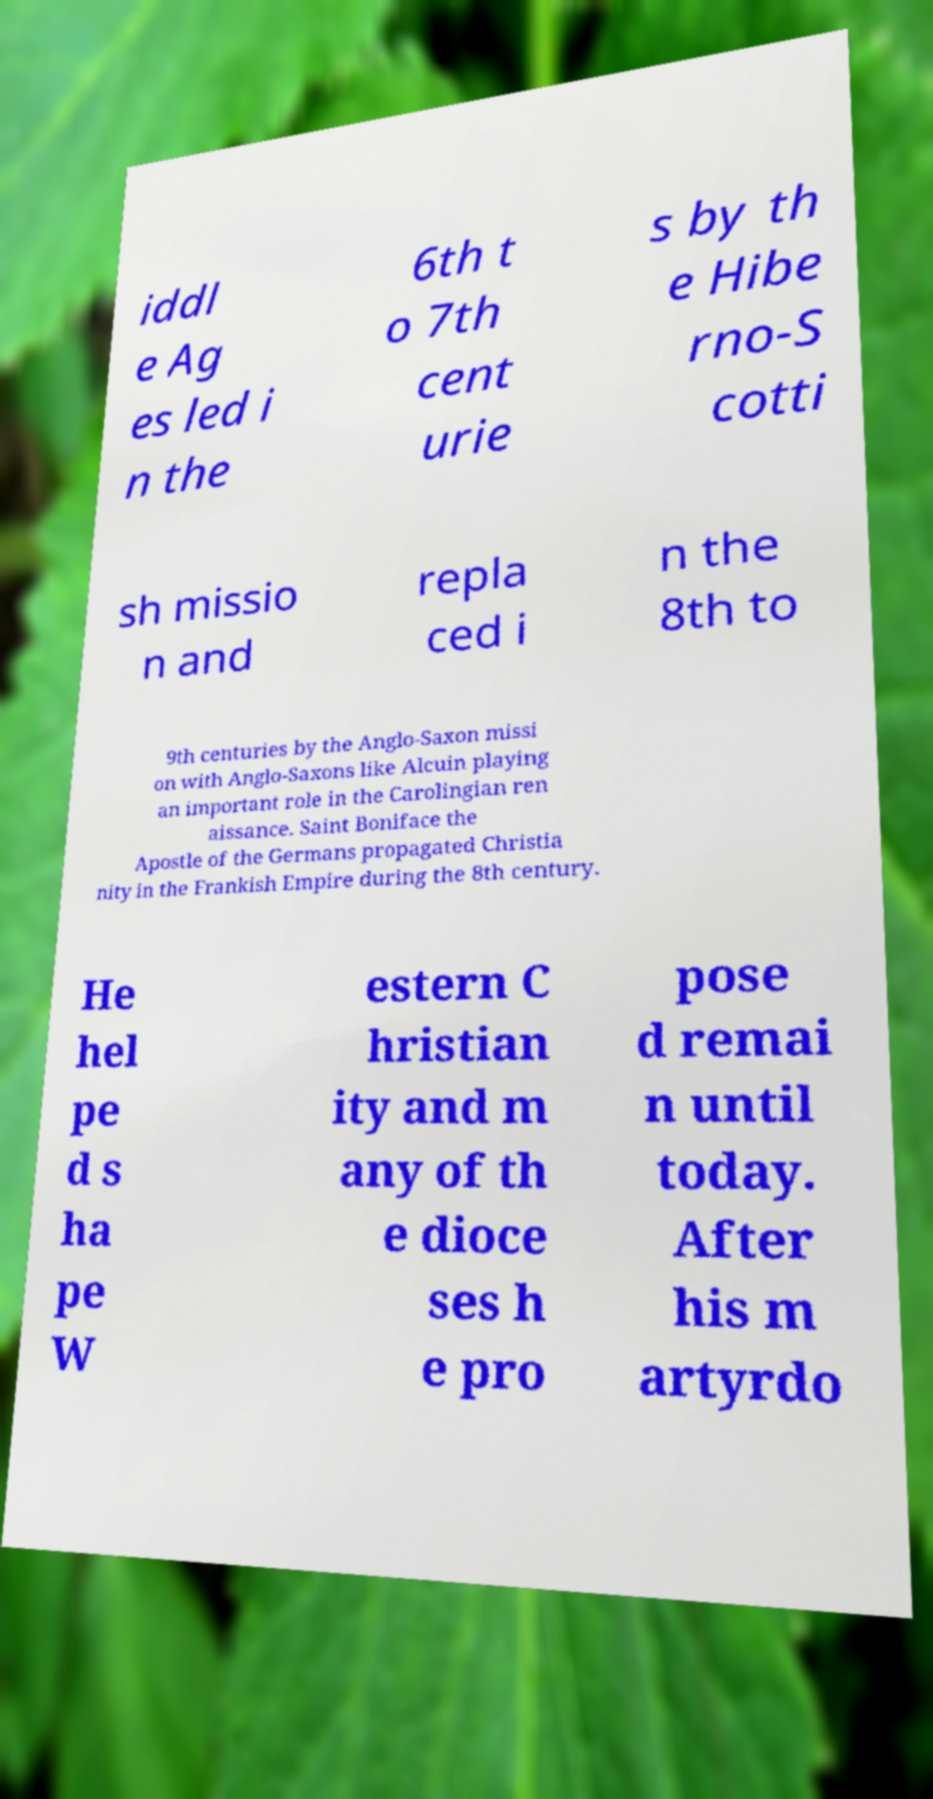What messages or text are displayed in this image? I need them in a readable, typed format. iddl e Ag es led i n the 6th t o 7th cent urie s by th e Hibe rno-S cotti sh missio n and repla ced i n the 8th to 9th centuries by the Anglo-Saxon missi on with Anglo-Saxons like Alcuin playing an important role in the Carolingian ren aissance. Saint Boniface the Apostle of the Germans propagated Christia nity in the Frankish Empire during the 8th century. He hel pe d s ha pe W estern C hristian ity and m any of th e dioce ses h e pro pose d remai n until today. After his m artyrdo 